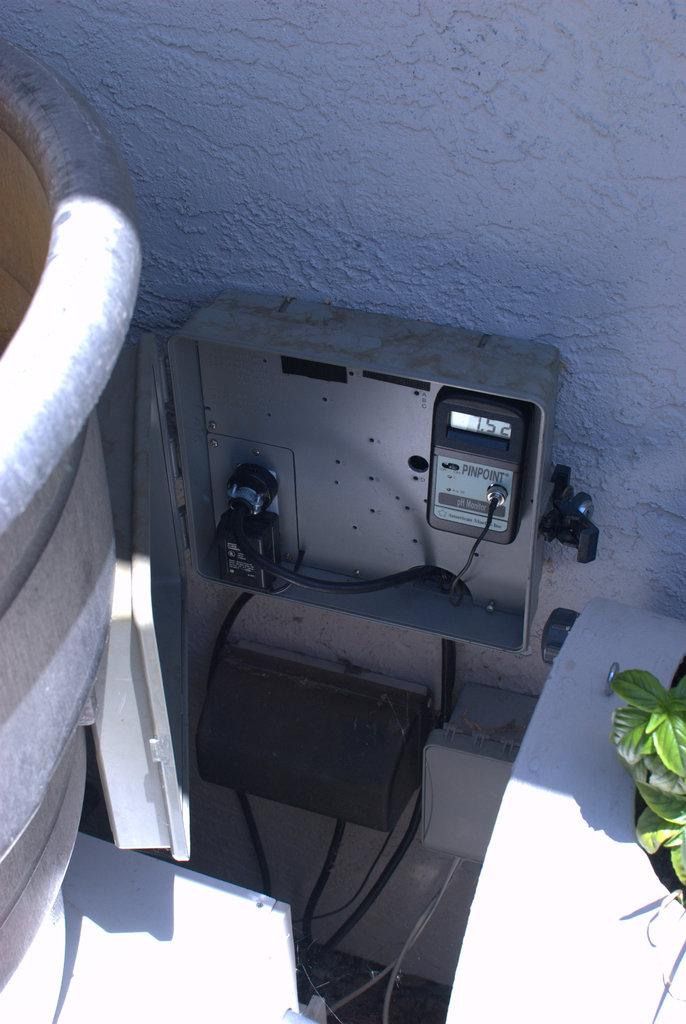What device is the main subject of the image? There is an electric-meter in the image. Where is the electric-meter attached? The electric-meter is attached to a white wall. What type of vegetation can be seen in the image? There are leaves visible in the image. What else is present in the image besides the electric-meter? There are wires in the image. What color is the object that the electric-meter is attached to? The wall the electric-meter is attached to is white. What makes the electric-meter cry in the image? The electric-meter does not cry in the image, as it is an inanimate object and cannot experience emotions. 